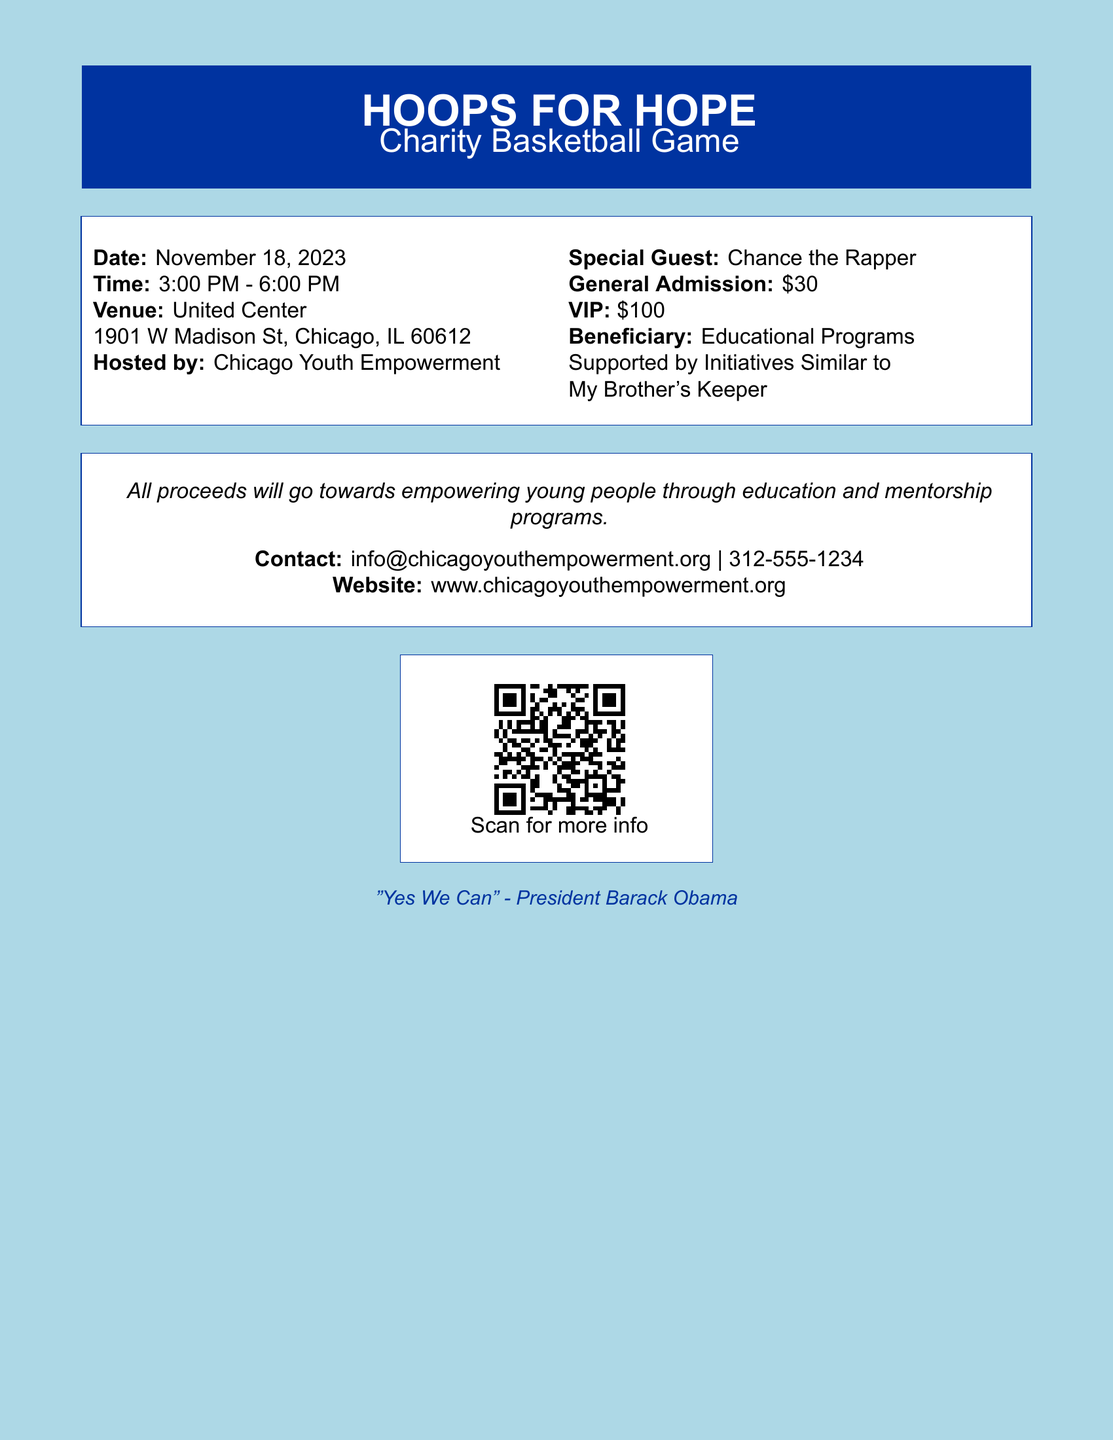What is the name of the event? The name of the event is stated at the top of the document, highlighting its purpose.
Answer: HOOPS FOR HOPE When is the charity basketball game? The date is clearly mentioned in the document, indicating when the event will take place.
Answer: November 18, 2023 What time does the event start? The starting time of the event is listed in the schedule provided in the document.
Answer: 3:00 PM Who is the special guest? The document specifies a celebrity guest who will be present at the event.
Answer: Chance the Rapper How much does general admission cost? The document provides pricing information for different ticket types, including general admission.
Answer: $30 What is the venue for the event? The venue is stated in the document, showing where the event will be held.
Answer: United Center What is the focus of the fundraising? The document mentions the beneficiary of the funds raised during the event.
Answer: Educational Programs What is the contact number for inquiries? The document lists contact information for any questions regarding the event.
Answer: 312-555-1234 How will the proceeds be utilized? The intention behind the event proceeds is mentioned in a statement within the document.
Answer: Empowering young people through education and mentorship programs 